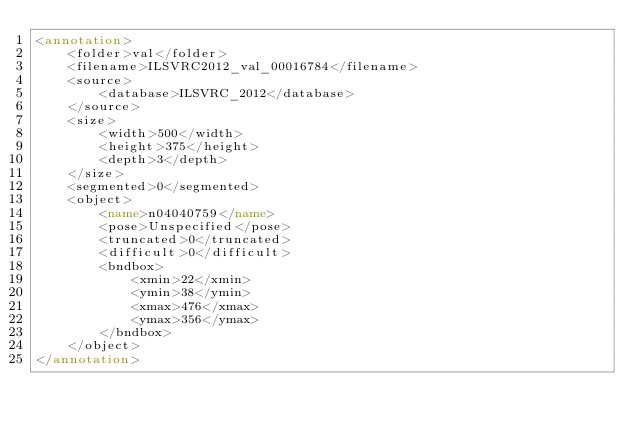Convert code to text. <code><loc_0><loc_0><loc_500><loc_500><_XML_><annotation>
	<folder>val</folder>
	<filename>ILSVRC2012_val_00016784</filename>
	<source>
		<database>ILSVRC_2012</database>
	</source>
	<size>
		<width>500</width>
		<height>375</height>
		<depth>3</depth>
	</size>
	<segmented>0</segmented>
	<object>
		<name>n04040759</name>
		<pose>Unspecified</pose>
		<truncated>0</truncated>
		<difficult>0</difficult>
		<bndbox>
			<xmin>22</xmin>
			<ymin>38</ymin>
			<xmax>476</xmax>
			<ymax>356</ymax>
		</bndbox>
	</object>
</annotation></code> 